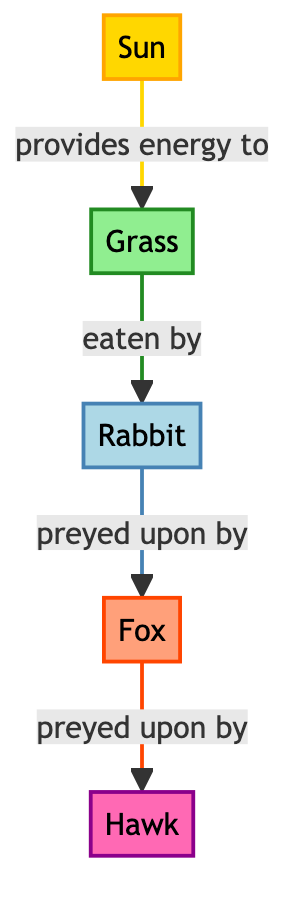What is the energy source in this food chain? The energy source, which provides energy to the food chain, is represented by the node labeled "Sun" in the diagram.
Answer: Sun How many nodes are in the diagram? The diagram contains five nodes: Sun, Grass, Rabbit, Fox, and Hawk.
Answer: 5 What do rabbits eat? According to the diagram, rabbits eat grass, which is represented by the edge connecting the rabbit and grass nodes.
Answer: Grass Which organism is at the top of the food chain? The apex predator in this food chain is indicated by the node labeled "Hawk," which is the topmost organism in the hierarchy of predation.
Answer: Hawk What is the relationship between foxes and rabbits? The relationship is described as "preyed upon by," indicating that foxes are predators that hunt and consume rabbits.
Answer: preyed upon by If a rabbit population decreases, what might happen to the fox population? If the rabbit population decreases, the fox population may also decline due to reduced food availability, as foxes rely on rabbits as a primary food source.
Answer: decrease How many types of organisms are in this food chain? There are three types of organisms represented in the food chain: producer (grass), herbivore (rabbit), and predator (fox, hawk).
Answer: 3 Which organism directly consumes grass? The organism that directly consumes grass is the rabbit, as indicated by the arrow showing the energy transfer from grass to rabbit.
Answer: Rabbit What is the role of the sun in this food chain? The role of the sun is to provide energy to the grass, which is the first step in the food chain, enabling the production of energy that supports the entire ecosystem.
Answer: provides energy to 